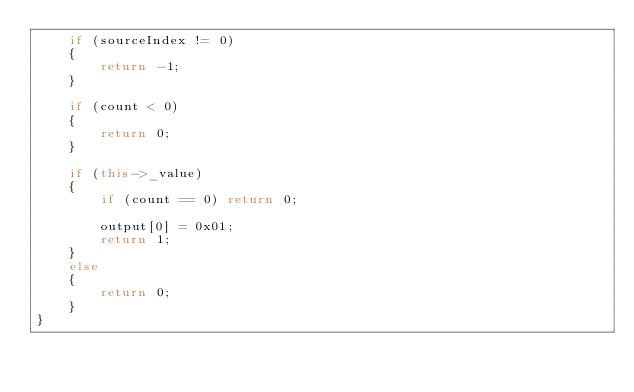Convert code to text. <code><loc_0><loc_0><loc_500><loc_500><_C++_>	if (sourceIndex != 0)
	{
		return -1;
	}

	if (count < 0)
	{
		return 0;
	}

	if (this->_value)
	{
		if (count == 0) return 0;

		output[0] = 0x01;
		return 1;
	}
	else
	{
		return 0;
	}
}</code> 